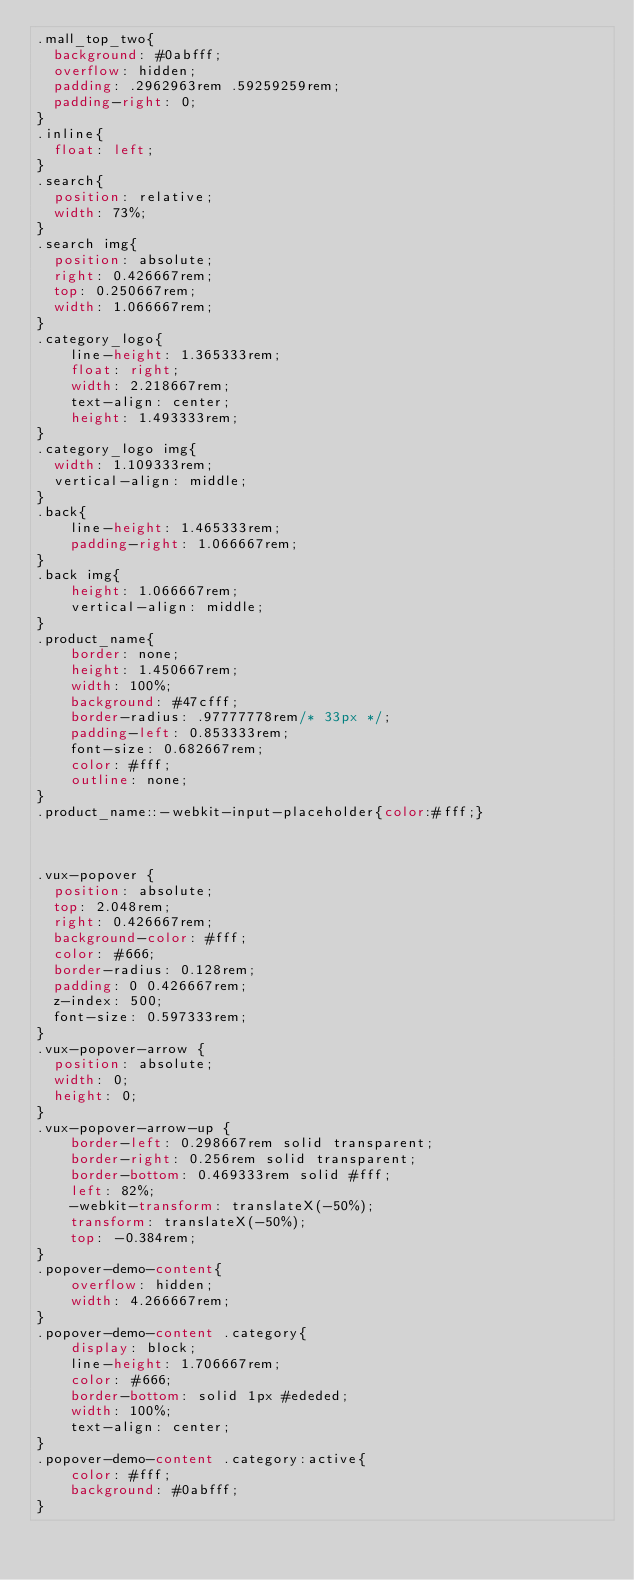<code> <loc_0><loc_0><loc_500><loc_500><_CSS_>.mall_top_two{
	background: #0abfff;
	overflow: hidden;
	padding: .2962963rem .59259259rem;
  padding-right: 0;
}
.inline{
	float: left;
}
.search{
	position: relative;
  width: 73%;
}
.search img{
	position: absolute;
	right: 0.426667rem;
	top: 0.250667rem;
	width: 1.066667rem;
}
.category_logo{
    line-height: 1.365333rem;
    float: right;
    width: 2.218667rem;
    text-align: center;
    height: 1.493333rem;
}
.category_logo img{
	width: 1.109333rem;
  vertical-align: middle;
}
.back{
    line-height: 1.465333rem;
    padding-right: 1.066667rem;
}
.back img{
    height: 1.066667rem;
    vertical-align: middle;
}
.product_name{
	  border: none;
    height: 1.450667rem;
    width: 100%;
    background: #47cfff;
    border-radius: .97777778rem/* 33px */;
    padding-left: 0.853333rem;
    font-size: 0.682667rem;
    color: #fff;
    outline: none;
}
.product_name::-webkit-input-placeholder{color:#fff;}



.vux-popover {
  position: absolute;
  top: 2.048rem;
  right: 0.426667rem;
  background-color: #fff;
  color: #666;
  border-radius: 0.128rem;
  padding: 0 0.426667rem;
  z-index: 500;
  font-size: 0.597333rem;
}
.vux-popover-arrow {
  position: absolute;
  width: 0;
  height: 0;
}
.vux-popover-arrow-up {
    border-left: 0.298667rem solid transparent;
    border-right: 0.256rem solid transparent;
    border-bottom: 0.469333rem solid #fff;
    left: 82%;
    -webkit-transform: translateX(-50%);
    transform: translateX(-50%);
    top: -0.384rem;
}
.popover-demo-content{
    overflow: hidden;
    width: 4.266667rem;
}
.popover-demo-content .category{
    display: block;
    line-height: 1.706667rem;
    color: #666;
    border-bottom: solid 1px #ededed;
    width: 100%;
    text-align: center;
}
.popover-demo-content .category:active{
    color: #fff;
    background: #0abfff;
}</code> 